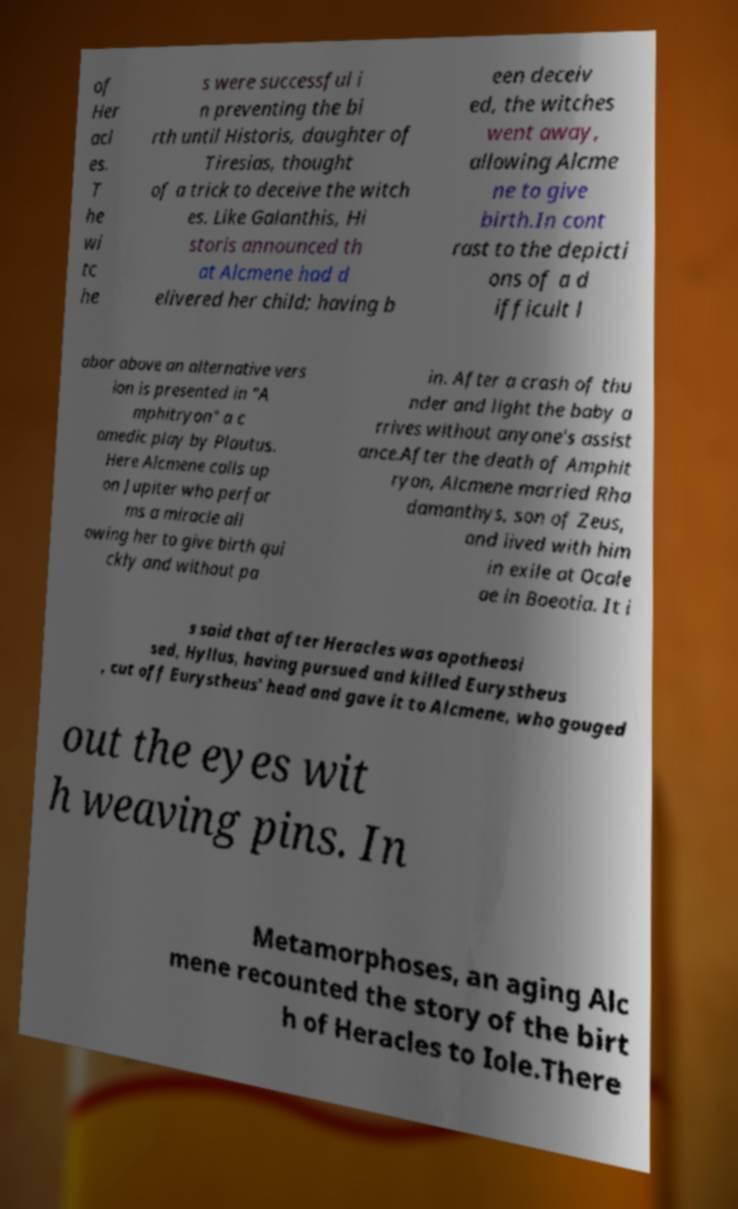Please identify and transcribe the text found in this image. of Her acl es. T he wi tc he s were successful i n preventing the bi rth until Historis, daughter of Tiresias, thought of a trick to deceive the witch es. Like Galanthis, Hi storis announced th at Alcmene had d elivered her child; having b een deceiv ed, the witches went away, allowing Alcme ne to give birth.In cont rast to the depicti ons of a d ifficult l abor above an alternative vers ion is presented in "A mphitryon" a c omedic play by Plautus. Here Alcmene calls up on Jupiter who perfor ms a miracle all owing her to give birth qui ckly and without pa in. After a crash of thu nder and light the baby a rrives without anyone's assist ance.After the death of Amphit ryon, Alcmene married Rha damanthys, son of Zeus, and lived with him in exile at Ocale ae in Boeotia. It i s said that after Heracles was apotheosi sed, Hyllus, having pursued and killed Eurystheus , cut off Eurystheus' head and gave it to Alcmene, who gouged out the eyes wit h weaving pins. In Metamorphoses, an aging Alc mene recounted the story of the birt h of Heracles to Iole.There 